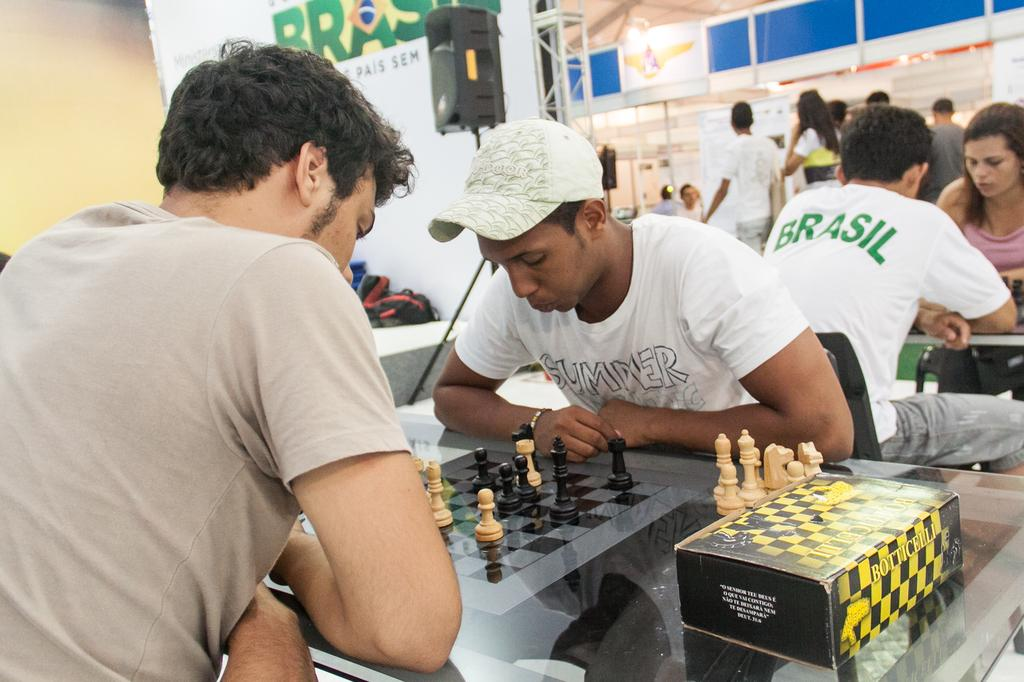<image>
Summarize the visual content of the image. People playing chess and a man is wearing a Brasil shirt 